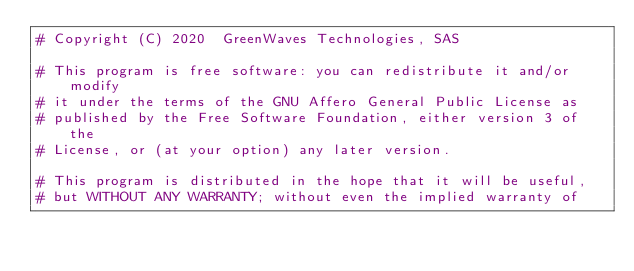Convert code to text. <code><loc_0><loc_0><loc_500><loc_500><_Python_># Copyright (C) 2020  GreenWaves Technologies, SAS

# This program is free software: you can redistribute it and/or modify
# it under the terms of the GNU Affero General Public License as
# published by the Free Software Foundation, either version 3 of the
# License, or (at your option) any later version.

# This program is distributed in the hope that it will be useful,
# but WITHOUT ANY WARRANTY; without even the implied warranty of</code> 